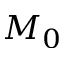<formula> <loc_0><loc_0><loc_500><loc_500>M _ { 0 }</formula> 